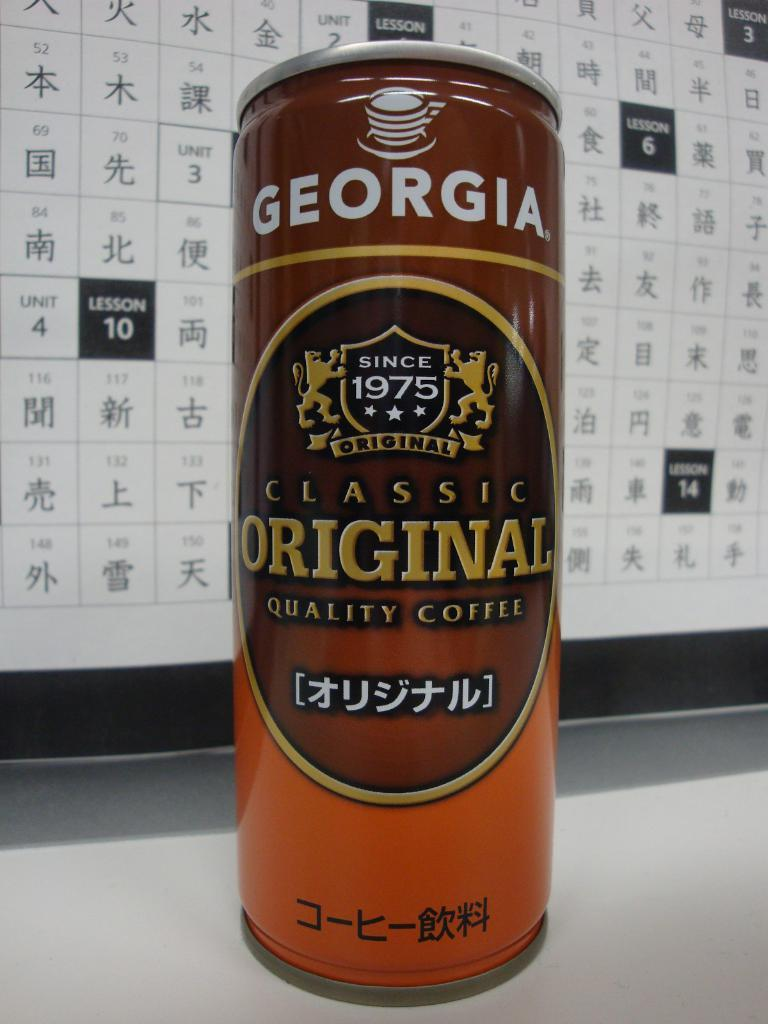What object is present in the image that is made of tin? There is a tin in the image. Where is the tin located in the image? The tin is on a surface in the image. What can be found on the tin? There is text and labels on the tin. What language is visible in the background of the image? There is text in Chinese visible in the background of the image. What type of cushion is being used to support the bread in the image? There is no cushion or bread present in the image; it only features a tin with text and labels on it. 